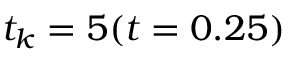<formula> <loc_0><loc_0><loc_500><loc_500>t _ { k } = 5 ( t = 0 . 2 5 )</formula> 